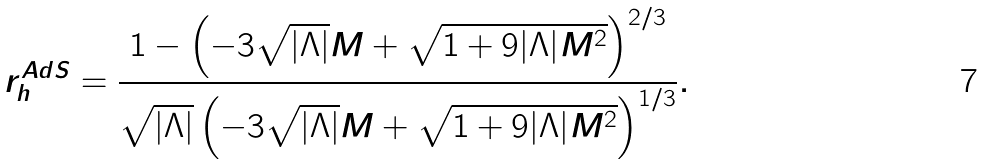Convert formula to latex. <formula><loc_0><loc_0><loc_500><loc_500>r _ { h } ^ { A d S } = \frac { 1 - \left ( - 3 \sqrt { | \Lambda | } M + \sqrt { 1 + 9 | \Lambda | M ^ { 2 } } \right ) ^ { 2 / 3 } } { \sqrt { | \Lambda | } \left ( - 3 \sqrt { | \Lambda | } M + \sqrt { 1 + 9 | \Lambda | M ^ { 2 } } \right ) ^ { 1 / 3 } } .</formula> 